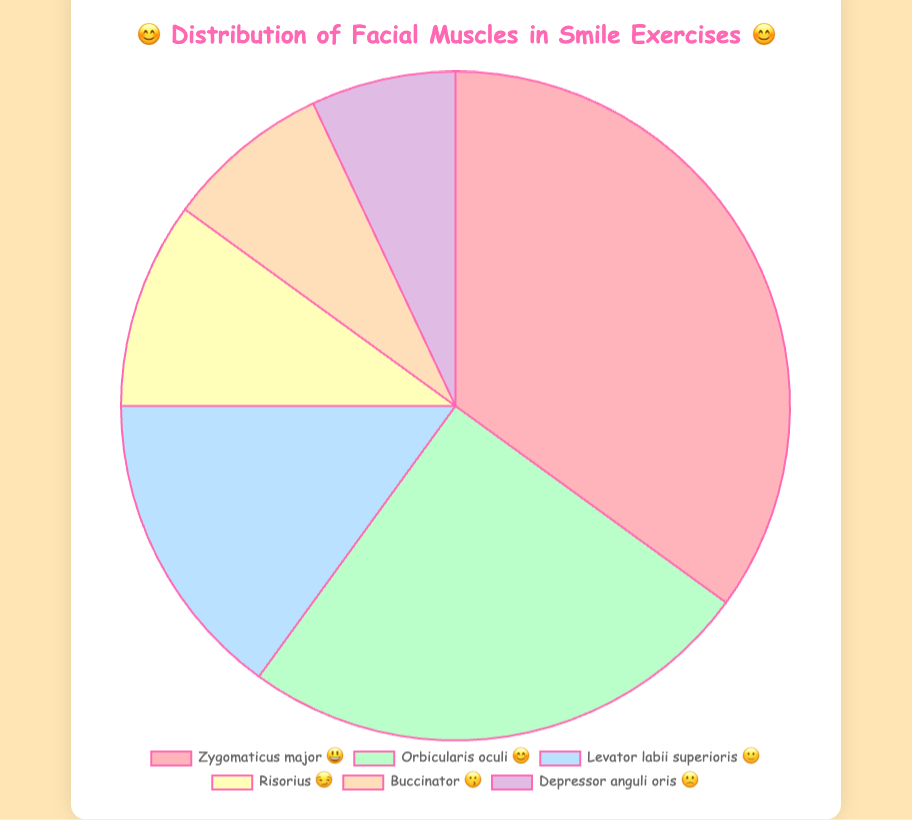What is the title of the chart? The title is prominently displayed at the top of the chart, it reads "😊 Distribution of Facial Muscles in Smile Exercises 😊".
Answer: 😊 Distribution of Facial Muscles in Smile Exercises 😊 Which facial muscle has the highest percentage? The facial muscle with the highest percentage can be found by viewing the largest slice or checking the labels in the legend. The Zygomaticus major has the highest percentage at 35%.
Answer: Zygomaticus major What percentage of exercises target the Orbicularis oculi muscle? Check the slice labeled "Orbicularis oculi" and read its corresponding percentage from either the slice itself or the legend. The Orbicularis oculi is targeted in 25% of the exercises.
Answer: 25% Which facial muscle is represented by the 🙂 emoji? Refer to the legend that matches muscle names with their respective emojis and percentages. The Levator labii superioris is represented by the 🙂 emoji.
Answer: Levator labii superioris How many muscles have a percentage less than 10%? Identify slices in the chart or entries in the legend with percentages below 10%. The Buccinator (8%) and Depressor anguli oris (7%) fall into this category.
Answer: 2 muscles What is the combined percentage of the Risorius and Buccinator muscles? Add the percentages of each of the Risorius and Buccinator muscles by finding their individual values: 10% + 8%.
Answer: 18% By what percentage is the Orbicularis oculi more targeted than the Levator labii superioris? Subtract the percentage of the Levator labii superioris from that of the Orbicularis oculi: 25% - 15%.
Answer: 10% How does the percentage of the Zygomaticus major compare to that of the Risorius? Compare the values directly: the Zygomaticus major is 35% and the Risorius is 10%, so Zygomaticus major has a higher percentage.
Answer: Zygomaticus major has a higher percentage Which muscle has the lowest percentage and what emoji represents it? The smallest slice or lowest percentage in the legend will indicate the muscle. The Depressor anguli oris is the lowest at 7%, represented by the 🙁 emoji.
Answer: Depressor anguli oris, 🙁 